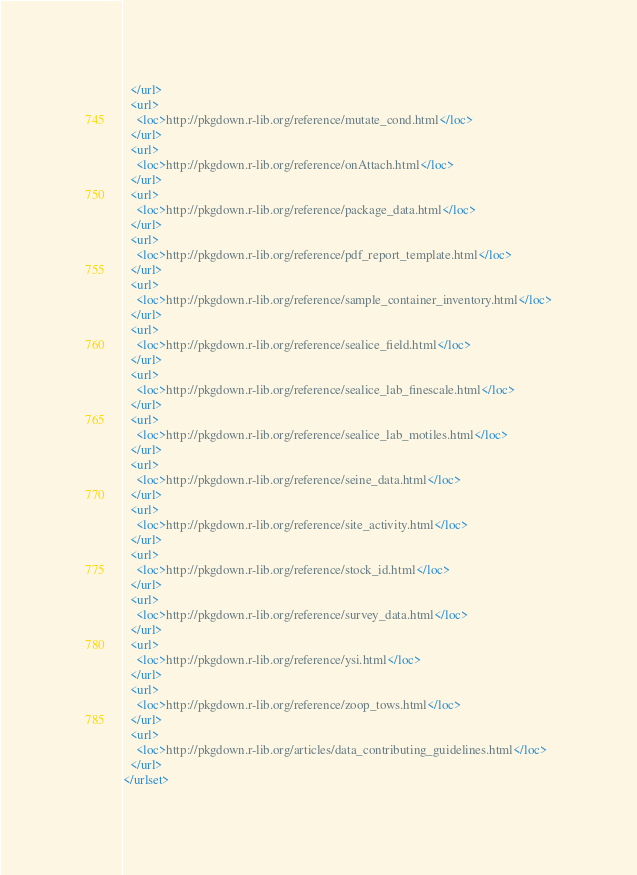Convert code to text. <code><loc_0><loc_0><loc_500><loc_500><_XML_>  </url>
  <url>
    <loc>http://pkgdown.r-lib.org/reference/mutate_cond.html</loc>
  </url>
  <url>
    <loc>http://pkgdown.r-lib.org/reference/onAttach.html</loc>
  </url>
  <url>
    <loc>http://pkgdown.r-lib.org/reference/package_data.html</loc>
  </url>
  <url>
    <loc>http://pkgdown.r-lib.org/reference/pdf_report_template.html</loc>
  </url>
  <url>
    <loc>http://pkgdown.r-lib.org/reference/sample_container_inventory.html</loc>
  </url>
  <url>
    <loc>http://pkgdown.r-lib.org/reference/sealice_field.html</loc>
  </url>
  <url>
    <loc>http://pkgdown.r-lib.org/reference/sealice_lab_finescale.html</loc>
  </url>
  <url>
    <loc>http://pkgdown.r-lib.org/reference/sealice_lab_motiles.html</loc>
  </url>
  <url>
    <loc>http://pkgdown.r-lib.org/reference/seine_data.html</loc>
  </url>
  <url>
    <loc>http://pkgdown.r-lib.org/reference/site_activity.html</loc>
  </url>
  <url>
    <loc>http://pkgdown.r-lib.org/reference/stock_id.html</loc>
  </url>
  <url>
    <loc>http://pkgdown.r-lib.org/reference/survey_data.html</loc>
  </url>
  <url>
    <loc>http://pkgdown.r-lib.org/reference/ysi.html</loc>
  </url>
  <url>
    <loc>http://pkgdown.r-lib.org/reference/zoop_tows.html</loc>
  </url>
  <url>
    <loc>http://pkgdown.r-lib.org/articles/data_contributing_guidelines.html</loc>
  </url>
</urlset>
</code> 